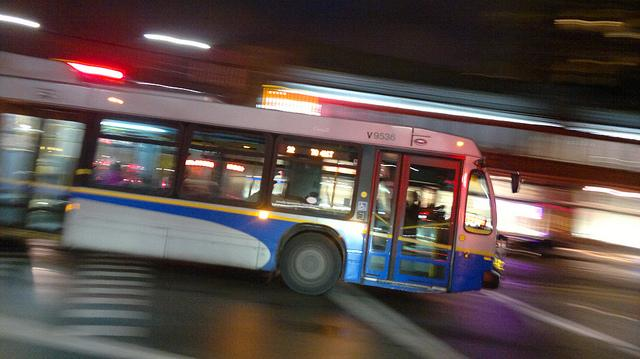Why is the bus blurred in the picture? moving 